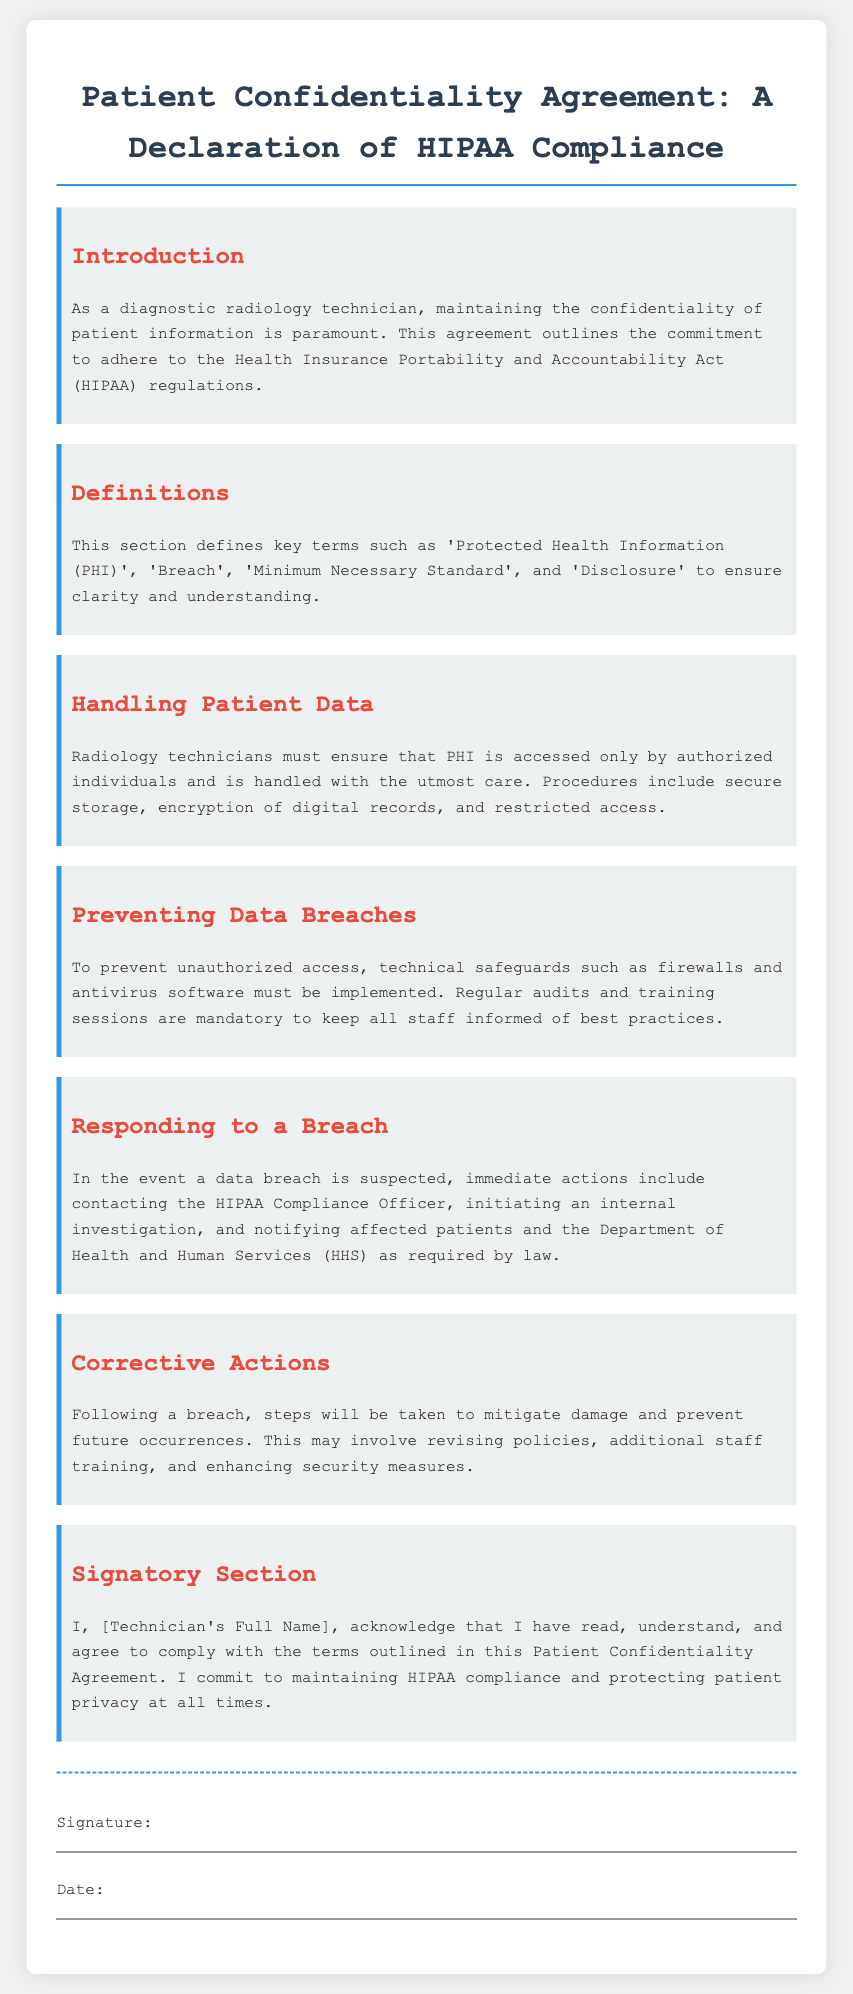What is the title of the document? The title can be found at the top of the document, which indicates the main topic.
Answer: Patient Confidentiality Agreement: A Declaration of HIPAA Compliance What must radiology technicians ensure about PHI? This information is provided in the section about handling patient data, outlining a specific responsibility of the technicians.
Answer: Accessed only by authorized individuals What is the first action to take if a data breach is suspected? This question refers to the section on responding to a breach, where immediate actions are outlined.
Answer: Contacting the HIPAA Compliance Officer What type of safeguards are mentioned to prevent unauthorized access? This is based on the preventive measures discussed in the document regarding data breaches.
Answer: Technical safeguards What must be done after a data breach occurs? This question is related to the corrective actions that follow a breach, which are detailed in a specific section.
Answer: Steps will be taken to mitigate damage Who must acknowledge and sign the Patient Confidentiality Agreement? This is specified in the signatory section of the document where the responsible party's name is required.
Answer: Technician's Full Name 